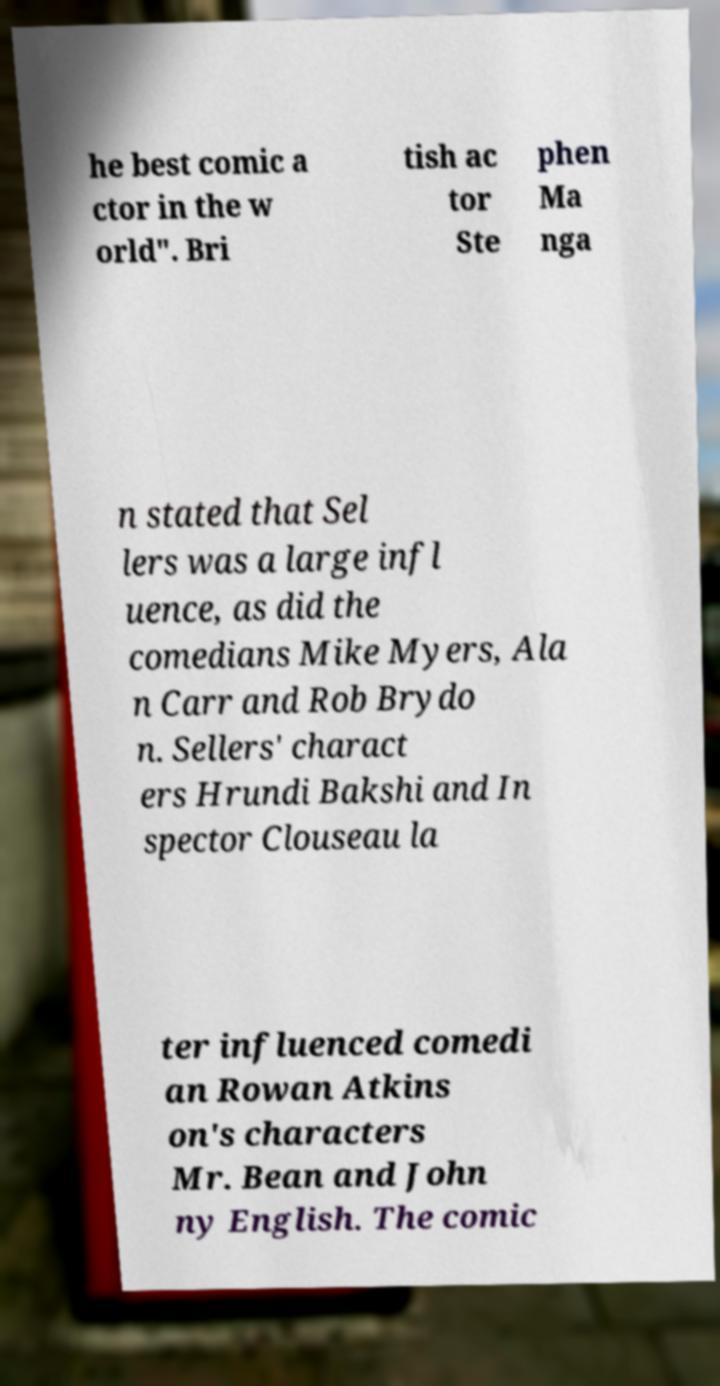Can you read and provide the text displayed in the image?This photo seems to have some interesting text. Can you extract and type it out for me? he best comic a ctor in the w orld". Bri tish ac tor Ste phen Ma nga n stated that Sel lers was a large infl uence, as did the comedians Mike Myers, Ala n Carr and Rob Brydo n. Sellers' charact ers Hrundi Bakshi and In spector Clouseau la ter influenced comedi an Rowan Atkins on's characters Mr. Bean and John ny English. The comic 